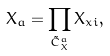<formula> <loc_0><loc_0><loc_500><loc_500>X _ { a } = \prod _ { \tilde { C } ^ { a } _ { X } } X _ { x i } ,</formula> 